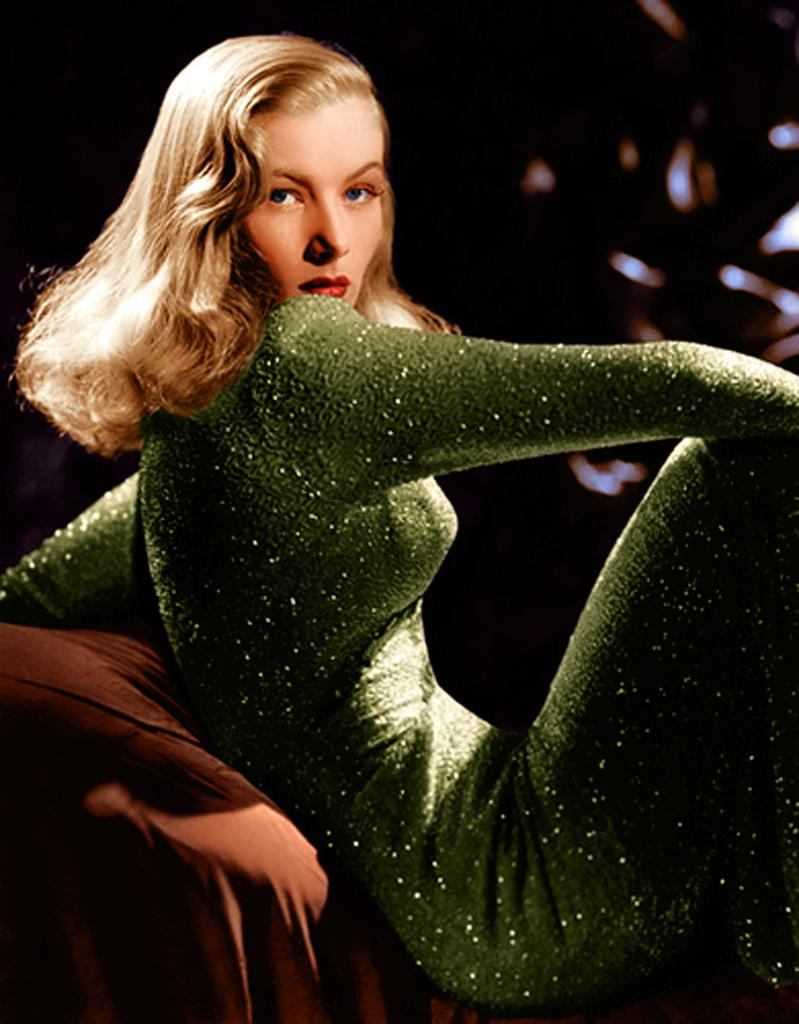Who is the main subject in the image? There is a woman in the image. What is the woman doing in the image? The woman is sitting on an object. What is the woman wearing in the image? The woman is wearing a green dress. What can be observed about the background of the image? The background of the image is dark. How much dirt is visible on the woman's shoes in the image? There is no dirt visible on the woman's shoes in the image, as the facts provided do not mention any dirt or shoes. 